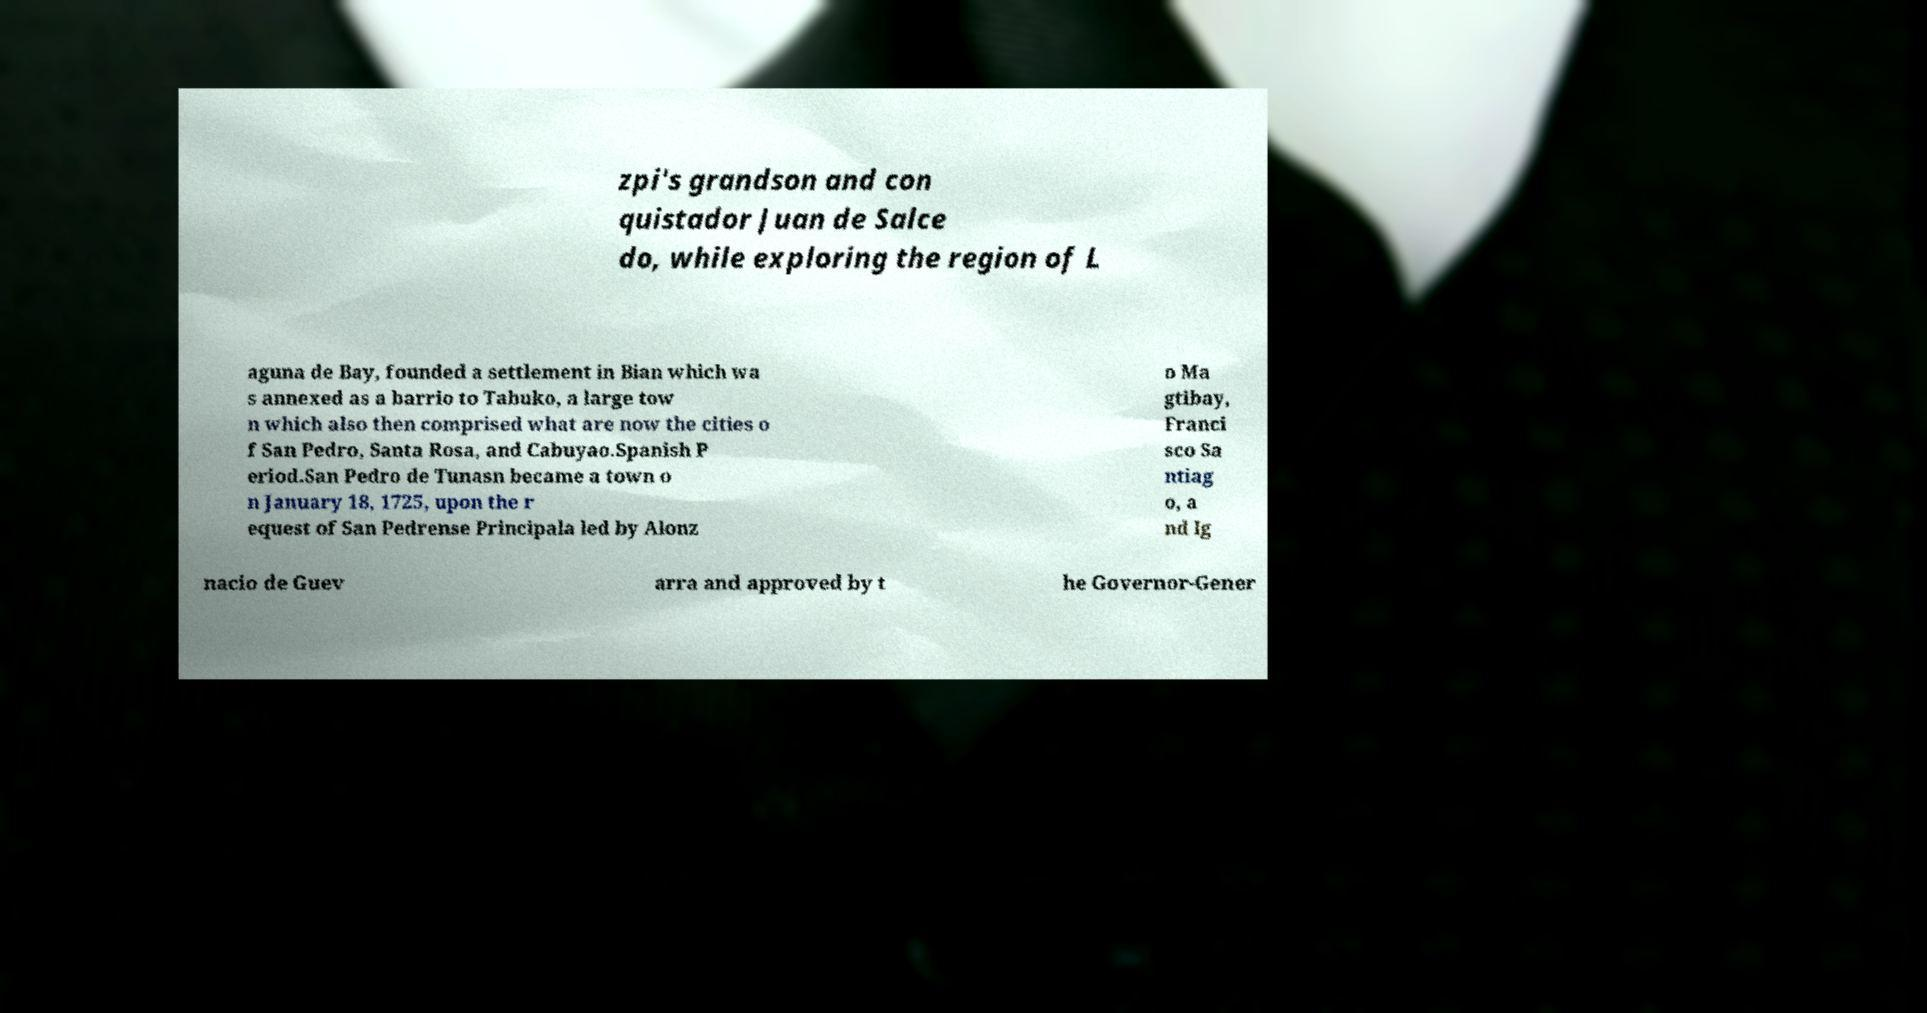For documentation purposes, I need the text within this image transcribed. Could you provide that? zpi's grandson and con quistador Juan de Salce do, while exploring the region of L aguna de Bay, founded a settlement in Bian which wa s annexed as a barrio to Tabuko, a large tow n which also then comprised what are now the cities o f San Pedro, Santa Rosa, and Cabuyao.Spanish P eriod.San Pedro de Tunasn became a town o n January 18, 1725, upon the r equest of San Pedrense Principala led by Alonz o Ma gtibay, Franci sco Sa ntiag o, a nd Ig nacio de Guev arra and approved by t he Governor-Gener 